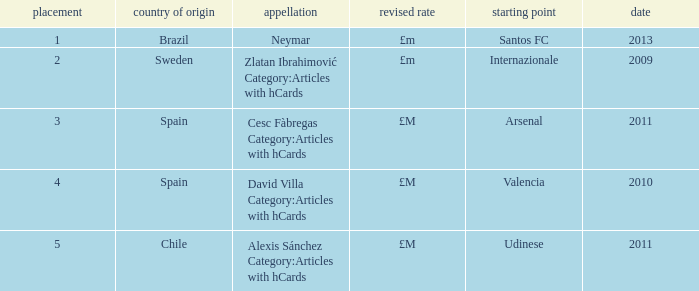What is the name of the player from Spain with a rank lower than 3? David Villa Category:Articles with hCards. 